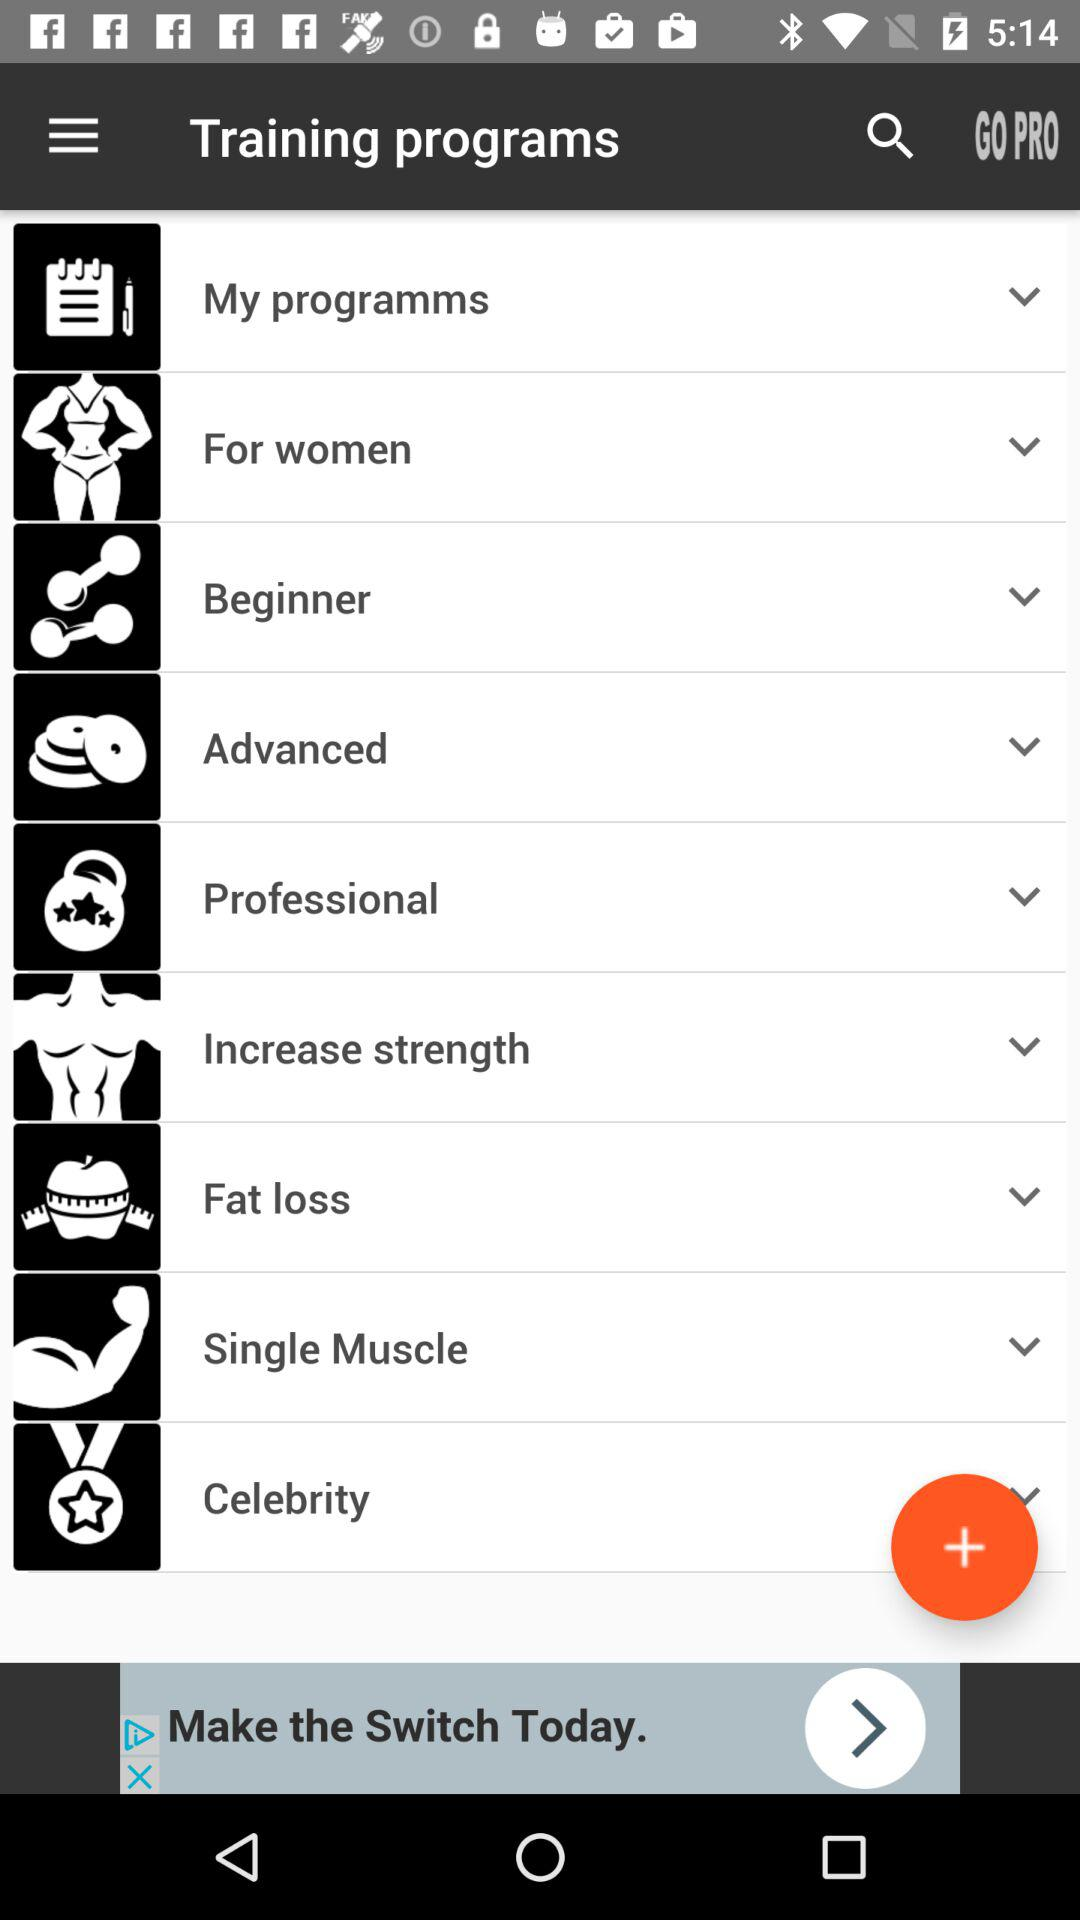Which types of training programs are available? The available types of training programs are "My programms", "For women", "Beginner", "Advanced", "Professional", "Increase strength", "Fat loss", "Single Muscle" and "Celebrity". 